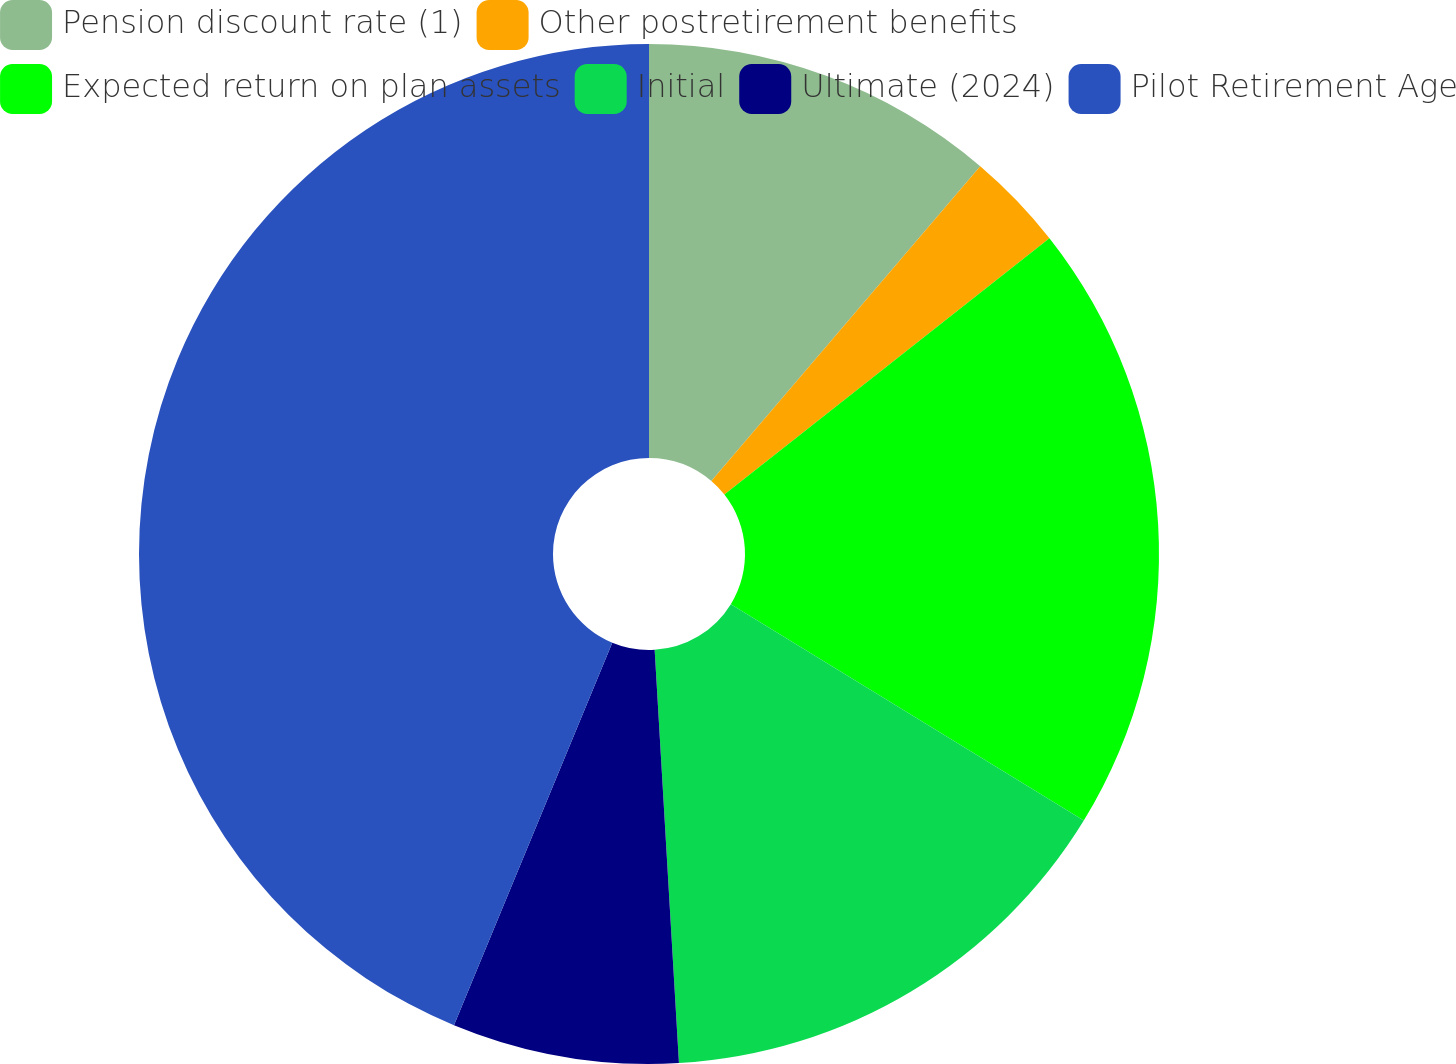Convert chart. <chart><loc_0><loc_0><loc_500><loc_500><pie_chart><fcel>Pension discount rate (1)<fcel>Other postretirement benefits<fcel>Expected return on plan assets<fcel>Initial<fcel>Ultimate (2024)<fcel>Pilot Retirement Age<nl><fcel>11.25%<fcel>3.12%<fcel>19.38%<fcel>15.31%<fcel>7.18%<fcel>43.75%<nl></chart> 